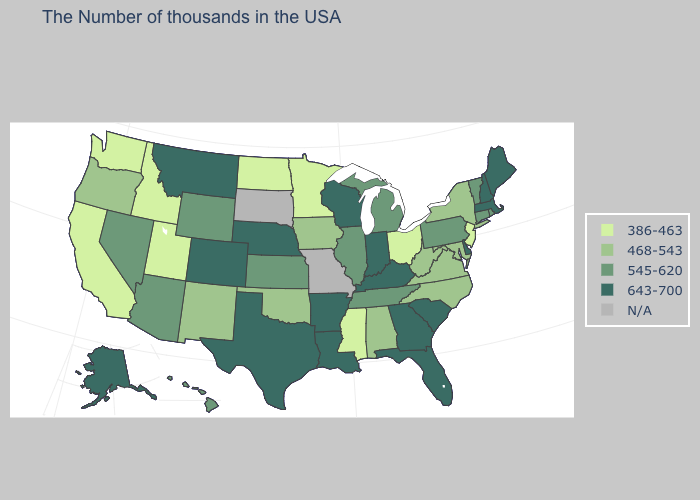Name the states that have a value in the range 643-700?
Quick response, please. Maine, Massachusetts, New Hampshire, Delaware, South Carolina, Florida, Georgia, Kentucky, Indiana, Wisconsin, Louisiana, Arkansas, Nebraska, Texas, Colorado, Montana, Alaska. Name the states that have a value in the range 386-463?
Be succinct. New Jersey, Ohio, Mississippi, Minnesota, North Dakota, Utah, Idaho, California, Washington. Among the states that border New York , does New Jersey have the highest value?
Answer briefly. No. Which states have the highest value in the USA?
Concise answer only. Maine, Massachusetts, New Hampshire, Delaware, South Carolina, Florida, Georgia, Kentucky, Indiana, Wisconsin, Louisiana, Arkansas, Nebraska, Texas, Colorado, Montana, Alaska. Among the states that border Alabama , does Tennessee have the highest value?
Write a very short answer. No. Among the states that border Oklahoma , does New Mexico have the lowest value?
Answer briefly. Yes. Does Wisconsin have the highest value in the USA?
Give a very brief answer. Yes. Does the first symbol in the legend represent the smallest category?
Short answer required. Yes. Does North Dakota have the highest value in the USA?
Give a very brief answer. No. Name the states that have a value in the range 386-463?
Quick response, please. New Jersey, Ohio, Mississippi, Minnesota, North Dakota, Utah, Idaho, California, Washington. Which states have the lowest value in the USA?
Give a very brief answer. New Jersey, Ohio, Mississippi, Minnesota, North Dakota, Utah, Idaho, California, Washington. Which states have the lowest value in the MidWest?
Answer briefly. Ohio, Minnesota, North Dakota. 